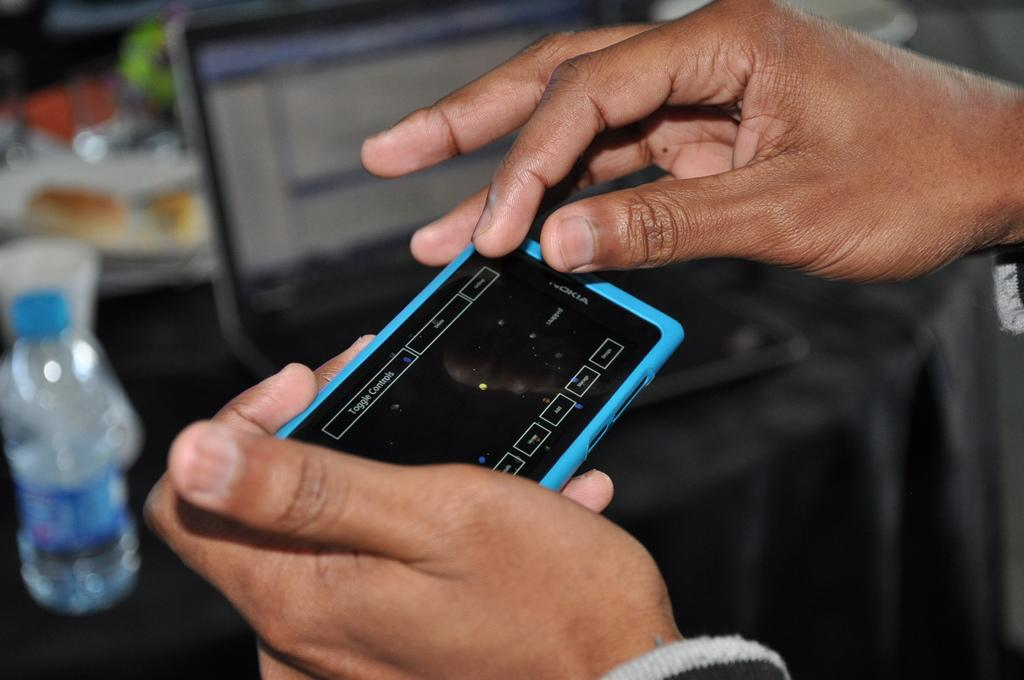Provide a one-sentence caption for the provided image. Someone holding a Nokia phone with a black screen. 